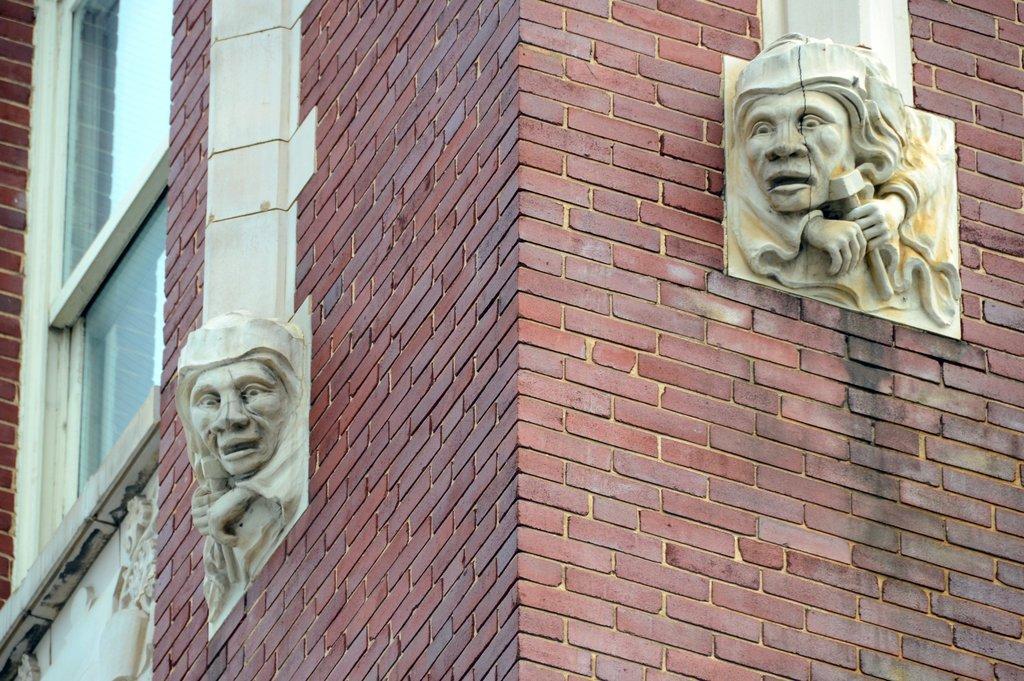Could you give a brief overview of what you see in this image? In this image we can see statues, walls, and a window. 